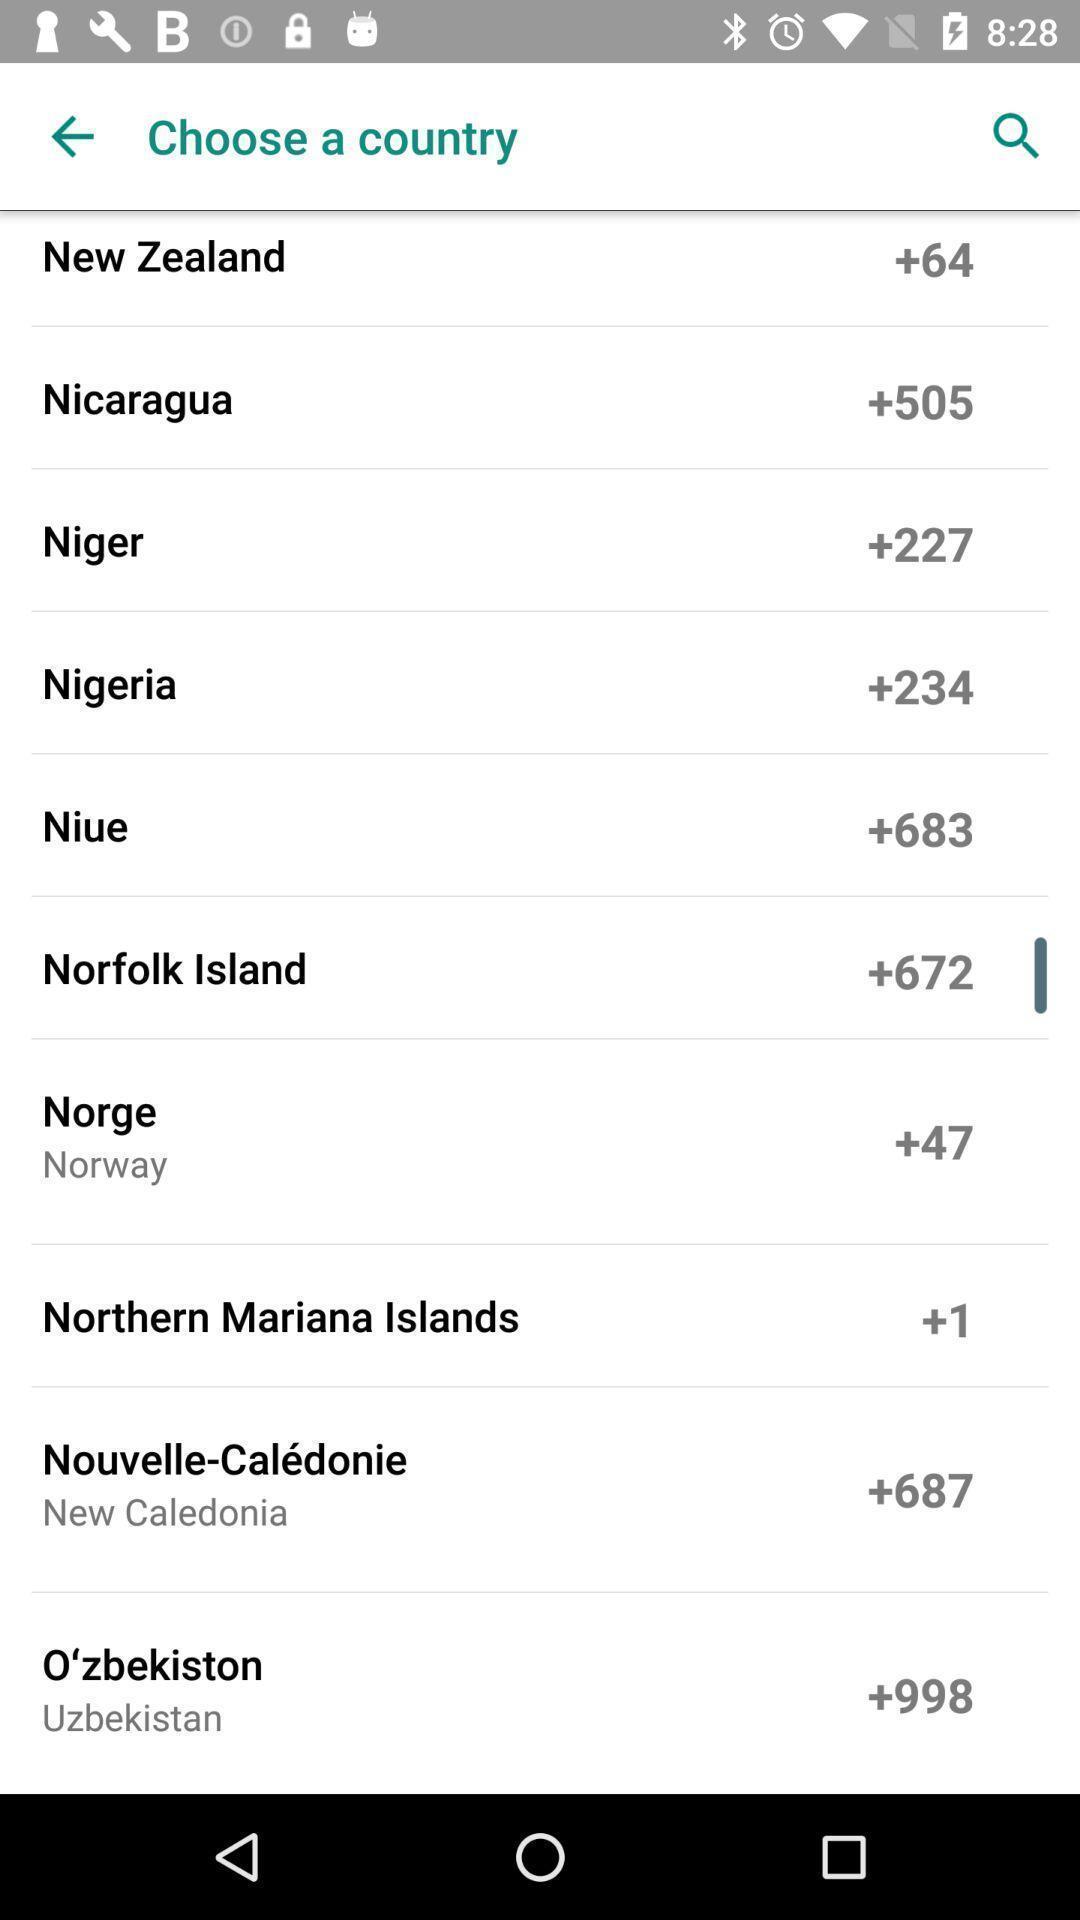Give me a narrative description of this picture. Page displaying the list of countries. 